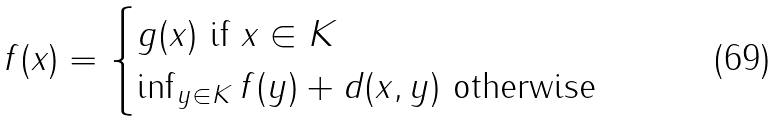<formula> <loc_0><loc_0><loc_500><loc_500>f ( x ) = \begin{cases} g ( x ) \text { if } x \in K \\ \inf _ { y \in K } f ( y ) + d ( x , y ) \text { otherwise} \end{cases}</formula> 